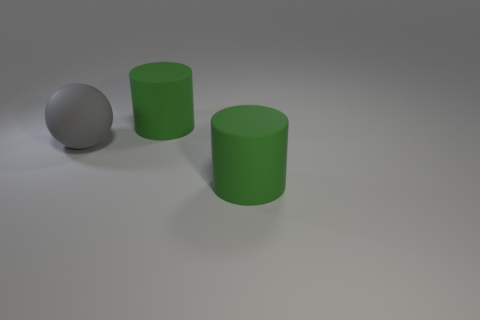Add 3 large green things. How many objects exist? 6 Subtract 2 cylinders. How many cylinders are left? 0 Add 1 gray balls. How many gray balls are left? 2 Add 1 large gray things. How many large gray things exist? 2 Subtract 0 blue balls. How many objects are left? 3 Subtract all cylinders. How many objects are left? 1 Subtract all cyan balls. Subtract all purple cylinders. How many balls are left? 1 Subtract all large gray things. Subtract all brown matte things. How many objects are left? 2 